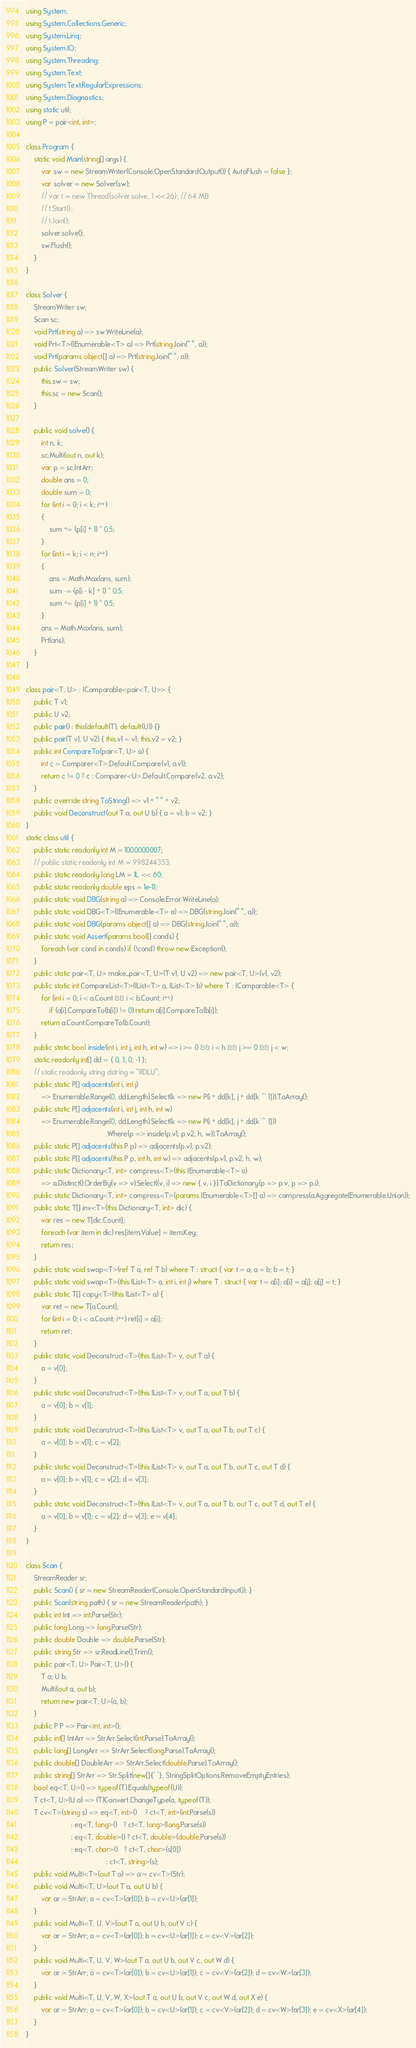<code> <loc_0><loc_0><loc_500><loc_500><_C#_>using System;
using System.Collections.Generic;
using System.Linq;
using System.IO;
using System.Threading;
using System.Text;
using System.Text.RegularExpressions;
using System.Diagnostics;
using static util;
using P = pair<int, int>;

class Program {
    static void Main(string[] args) {
        var sw = new StreamWriter(Console.OpenStandardOutput()) { AutoFlush = false };
        var solver = new Solver(sw);
        // var t = new Thread(solver.solve, 1 << 26); // 64 MB
        // t.Start();
        // t.Join();
        solver.solve();
        sw.Flush();
    }
}

class Solver {
    StreamWriter sw;
    Scan sc;
    void Prt(string a) => sw.WriteLine(a);
    void Prt<T>(IEnumerable<T> a) => Prt(string.Join(" ", a));
    void Prt(params object[] a) => Prt(string.Join(" ", a));
    public Solver(StreamWriter sw) {
        this.sw = sw;
        this.sc = new Scan();
    }

    public void solve() {
        int n, k;
        sc.Multi(out n, out k);
        var p = sc.IntArr;
        double ans = 0;
        double sum = 0;
        for (int i = 0; i < k; i++)
        {
            sum += (p[i] + 1) * 0.5;
        }
        for (int i = k; i < n; i++)
        {
            ans = Math.Max(ans, sum);
            sum -= (p[i - k] + 1) * 0.5;
            sum += (p[i] + 1) * 0.5;
        }
        ans = Math.Max(ans, sum);
        Prt(ans);
    }
}

class pair<T, U> : IComparable<pair<T, U>> {
    public T v1;
    public U v2;
    public pair() : this(default(T), default(U)) {}
    public pair(T v1, U v2) { this.v1 = v1; this.v2 = v2; }
    public int CompareTo(pair<T, U> a) {
        int c = Comparer<T>.Default.Compare(v1, a.v1);
        return c != 0 ? c : Comparer<U>.Default.Compare(v2, a.v2);
    }
    public override string ToString() => v1 + " " + v2;
    public void Deconstruct(out T a, out U b) { a = v1; b = v2; }
}
static class util {
    public static readonly int M = 1000000007;
    // public static readonly int M = 998244353;
    public static readonly long LM = 1L << 60;
    public static readonly double eps = 1e-11;
    public static void DBG(string a) => Console.Error.WriteLine(a);
    public static void DBG<T>(IEnumerable<T> a) => DBG(string.Join(" ", a));
    public static void DBG(params object[] a) => DBG(string.Join(" ", a));
    public static void Assert(params bool[] conds) {
        foreach (var cond in conds) if (!cond) throw new Exception();
    }
    public static pair<T, U> make_pair<T, U>(T v1, U v2) => new pair<T, U>(v1, v2);
    public static int CompareList<T>(IList<T> a, IList<T> b) where T : IComparable<T> {
        for (int i = 0; i < a.Count && i < b.Count; i++)
            if (a[i].CompareTo(b[i]) != 0) return a[i].CompareTo(b[i]);
        return a.Count.CompareTo(b.Count);
    }
    public static bool inside(int i, int j, int h, int w) => i >= 0 && i < h && j >= 0 && j < w;
    static readonly int[] dd = { 0, 1, 0, -1 };
    // static readonly string dstring = "RDLU";
    public static P[] adjacents(int i, int j)
        => Enumerable.Range(0, dd.Length).Select(k => new P(i + dd[k], j + dd[k ^ 1])).ToArray();
    public static P[] adjacents(int i, int j, int h, int w)
        => Enumerable.Range(0, dd.Length).Select(k => new P(i + dd[k], j + dd[k ^ 1]))
                                         .Where(p => inside(p.v1, p.v2, h, w)).ToArray();
    public static P[] adjacents(this P p) => adjacents(p.v1, p.v2);
    public static P[] adjacents(this P p, int h, int w) => adjacents(p.v1, p.v2, h, w);
    public static Dictionary<T, int> compress<T>(this IEnumerable<T> a)
        => a.Distinct().OrderBy(v => v).Select((v, i) => new { v, i }).ToDictionary(p => p.v, p => p.i);
    public static Dictionary<T, int> compress<T>(params IEnumerable<T>[] a) => compress(a.Aggregate(Enumerable.Union));
    public static T[] inv<T>(this Dictionary<T, int> dic) {
        var res = new T[dic.Count];
        foreach (var item in dic) res[item.Value] = item.Key;
        return res;
    }
    public static void swap<T>(ref T a, ref T b) where T : struct { var t = a; a = b; b = t; }
    public static void swap<T>(this IList<T> a, int i, int j) where T : struct { var t = a[i]; a[i] = a[j]; a[j] = t; }
    public static T[] copy<T>(this IList<T> a) {
        var ret = new T[a.Count];
        for (int i = 0; i < a.Count; i++) ret[i] = a[i];
        return ret;
    }
    public static void Deconstruct<T>(this IList<T> v, out T a) {
        a = v[0];
    }
    public static void Deconstruct<T>(this IList<T> v, out T a, out T b) {
        a = v[0]; b = v[1];
    }
    public static void Deconstruct<T>(this IList<T> v, out T a, out T b, out T c) {
        a = v[0]; b = v[1]; c = v[2];
    }
    public static void Deconstruct<T>(this IList<T> v, out T a, out T b, out T c, out T d) {
        a = v[0]; b = v[1]; c = v[2]; d = v[3];
    }
    public static void Deconstruct<T>(this IList<T> v, out T a, out T b, out T c, out T d, out T e) {
        a = v[0]; b = v[1]; c = v[2]; d = v[3]; e = v[4];
    }
}

class Scan {
    StreamReader sr;
    public Scan() { sr = new StreamReader(Console.OpenStandardInput()); }
    public Scan(string path) { sr = new StreamReader(path); }
    public int Int => int.Parse(Str);
    public long Long => long.Parse(Str);
    public double Double => double.Parse(Str);
    public string Str => sr.ReadLine().Trim();
    public pair<T, U> Pair<T, U>() {
        T a; U b;
        Multi(out a, out b);
        return new pair<T, U>(a, b);
    }
    public P P => Pair<int, int>();
    public int[] IntArr => StrArr.Select(int.Parse).ToArray();
    public long[] LongArr => StrArr.Select(long.Parse).ToArray();
    public double[] DoubleArr => StrArr.Select(double.Parse).ToArray();
    public string[] StrArr => Str.Split(new[]{' '}, StringSplitOptions.RemoveEmptyEntries);
    bool eq<T, U>() => typeof(T).Equals(typeof(U));
    T ct<T, U>(U a) => (T)Convert.ChangeType(a, typeof(T));
    T cv<T>(string s) => eq<T, int>()    ? ct<T, int>(int.Parse(s))
                       : eq<T, long>()   ? ct<T, long>(long.Parse(s))
                       : eq<T, double>() ? ct<T, double>(double.Parse(s))
                       : eq<T, char>()   ? ct<T, char>(s[0])
                                         : ct<T, string>(s);
    public void Multi<T>(out T a) => a = cv<T>(Str);
    public void Multi<T, U>(out T a, out U b) {
        var ar = StrArr; a = cv<T>(ar[0]); b = cv<U>(ar[1]);
    }
    public void Multi<T, U, V>(out T a, out U b, out V c) {
        var ar = StrArr; a = cv<T>(ar[0]); b = cv<U>(ar[1]); c = cv<V>(ar[2]);
    }
    public void Multi<T, U, V, W>(out T a, out U b, out V c, out W d) {
        var ar = StrArr; a = cv<T>(ar[0]); b = cv<U>(ar[1]); c = cv<V>(ar[2]); d = cv<W>(ar[3]);
    }
    public void Multi<T, U, V, W, X>(out T a, out U b, out V c, out W d, out X e) {
        var ar = StrArr; a = cv<T>(ar[0]); b = cv<U>(ar[1]); c = cv<V>(ar[2]); d = cv<W>(ar[3]); e = cv<X>(ar[4]);
    }
}
</code> 